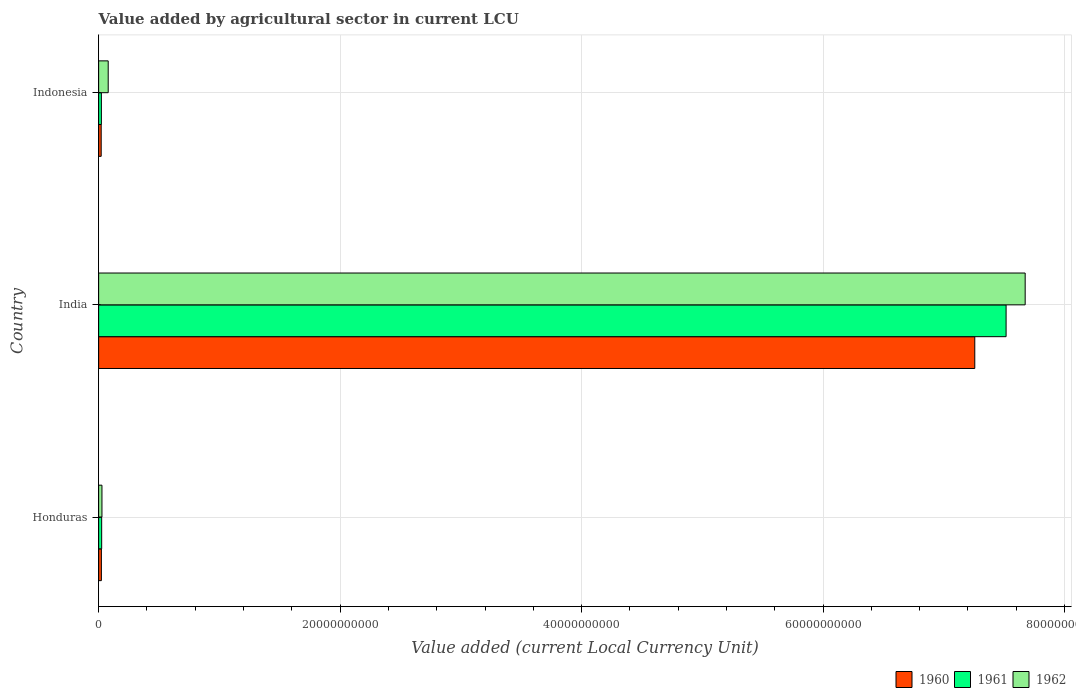How many different coloured bars are there?
Give a very brief answer. 3. What is the label of the 3rd group of bars from the top?
Provide a short and direct response. Honduras. In how many cases, is the number of bars for a given country not equal to the number of legend labels?
Give a very brief answer. 0. What is the value added by agricultural sector in 1962 in India?
Provide a short and direct response. 7.67e+1. Across all countries, what is the maximum value added by agricultural sector in 1961?
Your answer should be very brief. 7.52e+1. Across all countries, what is the minimum value added by agricultural sector in 1961?
Provide a short and direct response. 2.27e+08. In which country was the value added by agricultural sector in 1960 maximum?
Your response must be concise. India. What is the total value added by agricultural sector in 1961 in the graph?
Keep it short and to the point. 7.56e+1. What is the difference between the value added by agricultural sector in 1960 in Honduras and that in India?
Make the answer very short. -7.23e+1. What is the difference between the value added by agricultural sector in 1960 in India and the value added by agricultural sector in 1961 in Indonesia?
Ensure brevity in your answer.  7.23e+1. What is the average value added by agricultural sector in 1961 per country?
Give a very brief answer. 2.52e+1. What is the difference between the value added by agricultural sector in 1960 and value added by agricultural sector in 1961 in Indonesia?
Provide a succinct answer. -1.50e+07. What is the ratio of the value added by agricultural sector in 1960 in Honduras to that in Indonesia?
Make the answer very short. 1.07. What is the difference between the highest and the second highest value added by agricultural sector in 1962?
Keep it short and to the point. 7.59e+1. What is the difference between the highest and the lowest value added by agricultural sector in 1960?
Give a very brief answer. 7.24e+1. What does the 1st bar from the bottom in India represents?
Give a very brief answer. 1960. Is it the case that in every country, the sum of the value added by agricultural sector in 1960 and value added by agricultural sector in 1962 is greater than the value added by agricultural sector in 1961?
Provide a short and direct response. Yes. Are the values on the major ticks of X-axis written in scientific E-notation?
Offer a terse response. No. Does the graph contain any zero values?
Make the answer very short. No. Does the graph contain grids?
Your response must be concise. Yes. Where does the legend appear in the graph?
Provide a short and direct response. Bottom right. How many legend labels are there?
Give a very brief answer. 3. What is the title of the graph?
Offer a terse response. Value added by agricultural sector in current LCU. Does "1992" appear as one of the legend labels in the graph?
Provide a short and direct response. No. What is the label or title of the X-axis?
Give a very brief answer. Value added (current Local Currency Unit). What is the label or title of the Y-axis?
Provide a short and direct response. Country. What is the Value added (current Local Currency Unit) of 1960 in Honduras?
Ensure brevity in your answer.  2.27e+08. What is the Value added (current Local Currency Unit) of 1961 in Honduras?
Keep it short and to the point. 2.51e+08. What is the Value added (current Local Currency Unit) of 1962 in Honduras?
Your answer should be very brief. 2.74e+08. What is the Value added (current Local Currency Unit) of 1960 in India?
Offer a very short reply. 7.26e+1. What is the Value added (current Local Currency Unit) in 1961 in India?
Make the answer very short. 7.52e+1. What is the Value added (current Local Currency Unit) of 1962 in India?
Your response must be concise. 7.67e+1. What is the Value added (current Local Currency Unit) of 1960 in Indonesia?
Keep it short and to the point. 2.12e+08. What is the Value added (current Local Currency Unit) of 1961 in Indonesia?
Provide a short and direct response. 2.27e+08. What is the Value added (current Local Currency Unit) of 1962 in Indonesia?
Offer a terse response. 7.93e+08. Across all countries, what is the maximum Value added (current Local Currency Unit) of 1960?
Ensure brevity in your answer.  7.26e+1. Across all countries, what is the maximum Value added (current Local Currency Unit) of 1961?
Your answer should be compact. 7.52e+1. Across all countries, what is the maximum Value added (current Local Currency Unit) in 1962?
Offer a very short reply. 7.67e+1. Across all countries, what is the minimum Value added (current Local Currency Unit) in 1960?
Offer a very short reply. 2.12e+08. Across all countries, what is the minimum Value added (current Local Currency Unit) in 1961?
Ensure brevity in your answer.  2.27e+08. Across all countries, what is the minimum Value added (current Local Currency Unit) of 1962?
Your answer should be very brief. 2.74e+08. What is the total Value added (current Local Currency Unit) in 1960 in the graph?
Keep it short and to the point. 7.30e+1. What is the total Value added (current Local Currency Unit) of 1961 in the graph?
Offer a very short reply. 7.56e+1. What is the total Value added (current Local Currency Unit) of 1962 in the graph?
Offer a very short reply. 7.78e+1. What is the difference between the Value added (current Local Currency Unit) of 1960 in Honduras and that in India?
Make the answer very short. -7.23e+1. What is the difference between the Value added (current Local Currency Unit) of 1961 in Honduras and that in India?
Ensure brevity in your answer.  -7.49e+1. What is the difference between the Value added (current Local Currency Unit) in 1962 in Honduras and that in India?
Ensure brevity in your answer.  -7.65e+1. What is the difference between the Value added (current Local Currency Unit) of 1960 in Honduras and that in Indonesia?
Keep it short and to the point. 1.50e+07. What is the difference between the Value added (current Local Currency Unit) in 1961 in Honduras and that in Indonesia?
Keep it short and to the point. 2.42e+07. What is the difference between the Value added (current Local Currency Unit) in 1962 in Honduras and that in Indonesia?
Provide a short and direct response. -5.18e+08. What is the difference between the Value added (current Local Currency Unit) in 1960 in India and that in Indonesia?
Your response must be concise. 7.24e+1. What is the difference between the Value added (current Local Currency Unit) of 1961 in India and that in Indonesia?
Your response must be concise. 7.49e+1. What is the difference between the Value added (current Local Currency Unit) in 1962 in India and that in Indonesia?
Offer a very short reply. 7.59e+1. What is the difference between the Value added (current Local Currency Unit) of 1960 in Honduras and the Value added (current Local Currency Unit) of 1961 in India?
Provide a short and direct response. -7.49e+1. What is the difference between the Value added (current Local Currency Unit) in 1960 in Honduras and the Value added (current Local Currency Unit) in 1962 in India?
Provide a succinct answer. -7.65e+1. What is the difference between the Value added (current Local Currency Unit) in 1961 in Honduras and the Value added (current Local Currency Unit) in 1962 in India?
Give a very brief answer. -7.65e+1. What is the difference between the Value added (current Local Currency Unit) in 1960 in Honduras and the Value added (current Local Currency Unit) in 1961 in Indonesia?
Provide a succinct answer. 0. What is the difference between the Value added (current Local Currency Unit) in 1960 in Honduras and the Value added (current Local Currency Unit) in 1962 in Indonesia?
Provide a short and direct response. -5.66e+08. What is the difference between the Value added (current Local Currency Unit) of 1961 in Honduras and the Value added (current Local Currency Unit) of 1962 in Indonesia?
Keep it short and to the point. -5.42e+08. What is the difference between the Value added (current Local Currency Unit) in 1960 in India and the Value added (current Local Currency Unit) in 1961 in Indonesia?
Offer a very short reply. 7.23e+1. What is the difference between the Value added (current Local Currency Unit) in 1960 in India and the Value added (current Local Currency Unit) in 1962 in Indonesia?
Keep it short and to the point. 7.18e+1. What is the difference between the Value added (current Local Currency Unit) of 1961 in India and the Value added (current Local Currency Unit) of 1962 in Indonesia?
Provide a short and direct response. 7.44e+1. What is the average Value added (current Local Currency Unit) of 1960 per country?
Give a very brief answer. 2.43e+1. What is the average Value added (current Local Currency Unit) of 1961 per country?
Give a very brief answer. 2.52e+1. What is the average Value added (current Local Currency Unit) of 1962 per country?
Offer a terse response. 2.59e+1. What is the difference between the Value added (current Local Currency Unit) of 1960 and Value added (current Local Currency Unit) of 1961 in Honduras?
Make the answer very short. -2.42e+07. What is the difference between the Value added (current Local Currency Unit) in 1960 and Value added (current Local Currency Unit) in 1962 in Honduras?
Give a very brief answer. -4.75e+07. What is the difference between the Value added (current Local Currency Unit) of 1961 and Value added (current Local Currency Unit) of 1962 in Honduras?
Offer a terse response. -2.33e+07. What is the difference between the Value added (current Local Currency Unit) of 1960 and Value added (current Local Currency Unit) of 1961 in India?
Offer a terse response. -2.59e+09. What is the difference between the Value added (current Local Currency Unit) of 1960 and Value added (current Local Currency Unit) of 1962 in India?
Keep it short and to the point. -4.17e+09. What is the difference between the Value added (current Local Currency Unit) in 1961 and Value added (current Local Currency Unit) in 1962 in India?
Make the answer very short. -1.58e+09. What is the difference between the Value added (current Local Currency Unit) in 1960 and Value added (current Local Currency Unit) in 1961 in Indonesia?
Keep it short and to the point. -1.50e+07. What is the difference between the Value added (current Local Currency Unit) of 1960 and Value added (current Local Currency Unit) of 1962 in Indonesia?
Provide a short and direct response. -5.81e+08. What is the difference between the Value added (current Local Currency Unit) of 1961 and Value added (current Local Currency Unit) of 1962 in Indonesia?
Provide a succinct answer. -5.66e+08. What is the ratio of the Value added (current Local Currency Unit) of 1960 in Honduras to that in India?
Ensure brevity in your answer.  0. What is the ratio of the Value added (current Local Currency Unit) in 1961 in Honduras to that in India?
Your answer should be very brief. 0. What is the ratio of the Value added (current Local Currency Unit) of 1962 in Honduras to that in India?
Make the answer very short. 0. What is the ratio of the Value added (current Local Currency Unit) of 1960 in Honduras to that in Indonesia?
Provide a succinct answer. 1.07. What is the ratio of the Value added (current Local Currency Unit) in 1961 in Honduras to that in Indonesia?
Give a very brief answer. 1.11. What is the ratio of the Value added (current Local Currency Unit) in 1962 in Honduras to that in Indonesia?
Ensure brevity in your answer.  0.35. What is the ratio of the Value added (current Local Currency Unit) in 1960 in India to that in Indonesia?
Provide a succinct answer. 342.29. What is the ratio of the Value added (current Local Currency Unit) in 1961 in India to that in Indonesia?
Provide a short and direct response. 331.1. What is the ratio of the Value added (current Local Currency Unit) in 1962 in India to that in Indonesia?
Ensure brevity in your answer.  96.77. What is the difference between the highest and the second highest Value added (current Local Currency Unit) in 1960?
Your response must be concise. 7.23e+1. What is the difference between the highest and the second highest Value added (current Local Currency Unit) in 1961?
Your response must be concise. 7.49e+1. What is the difference between the highest and the second highest Value added (current Local Currency Unit) in 1962?
Offer a very short reply. 7.59e+1. What is the difference between the highest and the lowest Value added (current Local Currency Unit) of 1960?
Your response must be concise. 7.24e+1. What is the difference between the highest and the lowest Value added (current Local Currency Unit) of 1961?
Your answer should be compact. 7.49e+1. What is the difference between the highest and the lowest Value added (current Local Currency Unit) of 1962?
Offer a terse response. 7.65e+1. 